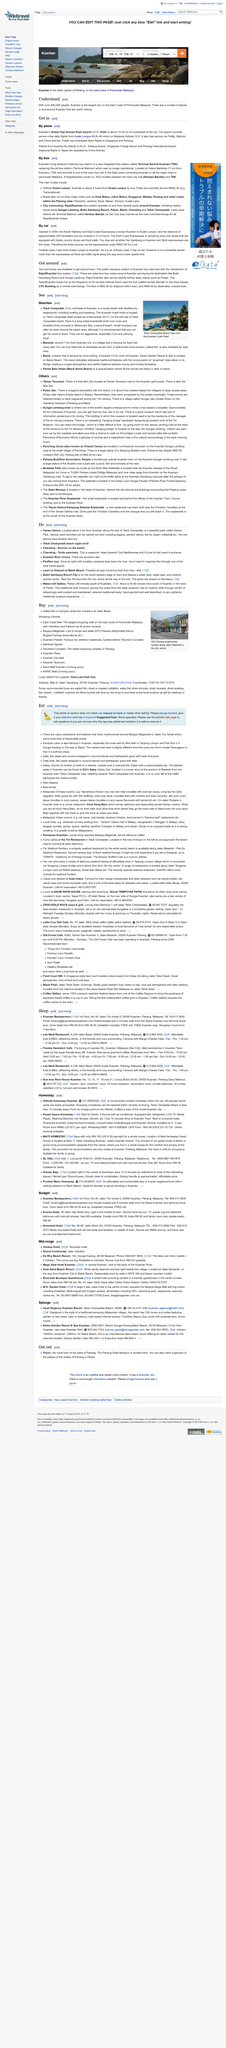Indicate a few pertinent items in this graphic. Yes, it is possible to get in by plane. Water sports such as boating and kayaking are included at Teluk Cempedak. Yes, Kuantan is the largest city on the East Coast of Peninsular Malaysia, making it a prime destination for travelers seeking a unique and exciting experience. Teluk Cempedak is located approximately 5 kilometers northeast of Kuantan. The population of Kuantan is over 600,000. 